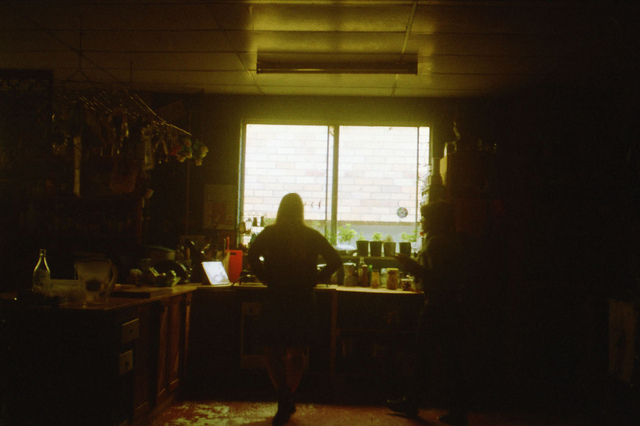Is the hallway wide or narrow? From what can be seen in the image, the hallway tends to be on the narrower side. The angle of the image and visible architectural elements limit the perception of width, making the hallway appear more constrained. 